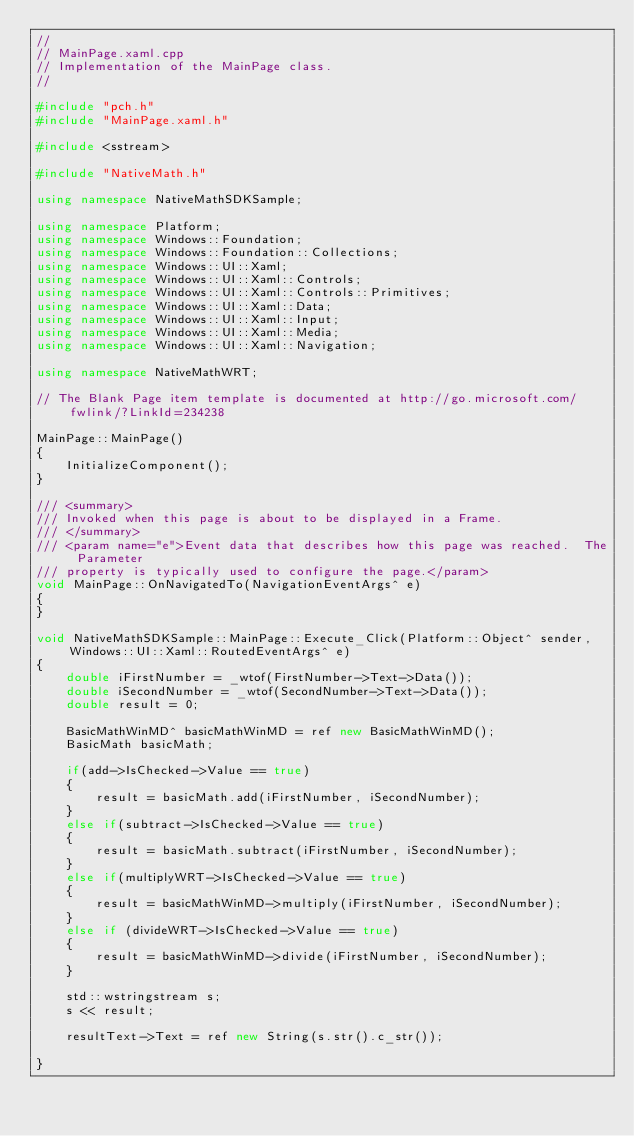Convert code to text. <code><loc_0><loc_0><loc_500><loc_500><_C++_>//
// MainPage.xaml.cpp
// Implementation of the MainPage class.
//

#include "pch.h"
#include "MainPage.xaml.h"

#include <sstream>

#include "NativeMath.h"

using namespace NativeMathSDKSample;

using namespace Platform;
using namespace Windows::Foundation;
using namespace Windows::Foundation::Collections;
using namespace Windows::UI::Xaml;
using namespace Windows::UI::Xaml::Controls;
using namespace Windows::UI::Xaml::Controls::Primitives;
using namespace Windows::UI::Xaml::Data;
using namespace Windows::UI::Xaml::Input;
using namespace Windows::UI::Xaml::Media;
using namespace Windows::UI::Xaml::Navigation;

using namespace NativeMathWRT;

// The Blank Page item template is documented at http://go.microsoft.com/fwlink/?LinkId=234238

MainPage::MainPage()
{
    InitializeComponent();
}

/// <summary>
/// Invoked when this page is about to be displayed in a Frame.
/// </summary>
/// <param name="e">Event data that describes how this page was reached.  The Parameter
/// property is typically used to configure the page.</param>
void MainPage::OnNavigatedTo(NavigationEventArgs^ e)
{
}

void NativeMathSDKSample::MainPage::Execute_Click(Platform::Object^ sender, Windows::UI::Xaml::RoutedEventArgs^ e)
{
    double iFirstNumber = _wtof(FirstNumber->Text->Data());
    double iSecondNumber = _wtof(SecondNumber->Text->Data());
    double result = 0;

    BasicMathWinMD^ basicMathWinMD = ref new BasicMathWinMD();
    BasicMath basicMath;

    if(add->IsChecked->Value == true)
    {
        result = basicMath.add(iFirstNumber, iSecondNumber);
    }
    else if(subtract->IsChecked->Value == true)
    {
        result = basicMath.subtract(iFirstNumber, iSecondNumber);
    }
    else if(multiplyWRT->IsChecked->Value == true)
    {
        result = basicMathWinMD->multiply(iFirstNumber, iSecondNumber);
    }
    else if (divideWRT->IsChecked->Value == true)
    {
        result = basicMathWinMD->divide(iFirstNumber, iSecondNumber);
    }

    std::wstringstream s;
    s << result;

    resultText->Text = ref new String(s.str().c_str());

}</code> 